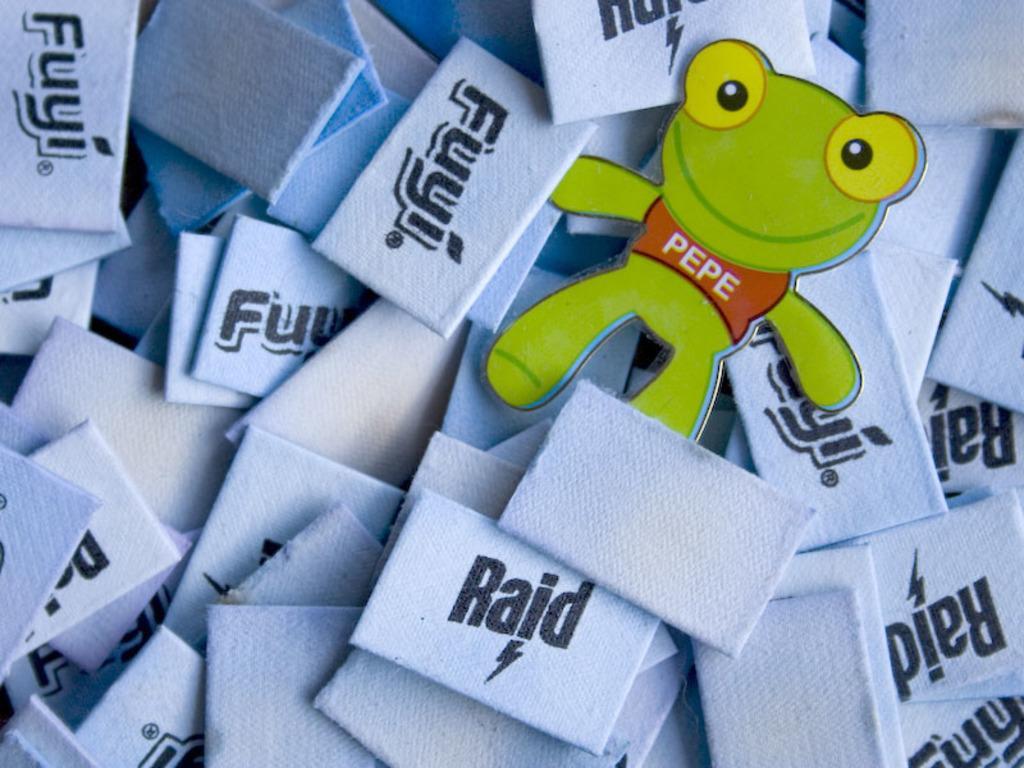Can you describe this image briefly? In this picture we can see the labels and cartoon image. 